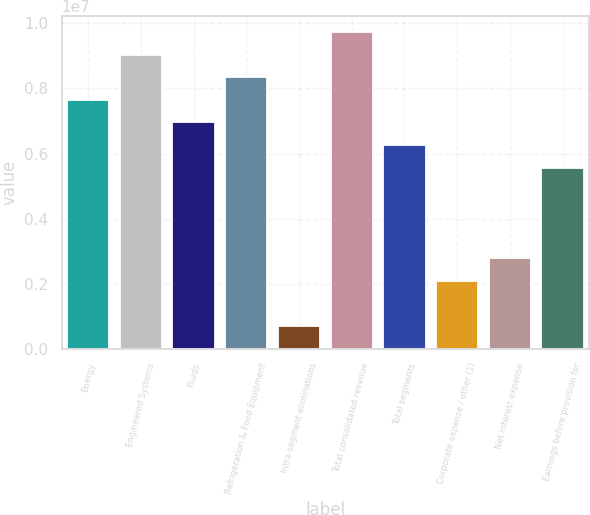Convert chart to OTSL. <chart><loc_0><loc_0><loc_500><loc_500><bar_chart><fcel>Energy<fcel>Engineered Systems<fcel>Fluids<fcel>Refrigeration & Food Equipment<fcel>Intra-segment eliminations<fcel>Total consolidated revenue<fcel>Total segments<fcel>Corporate expense / other (1)<fcel>Net interest expense<fcel>Earnings before provision for<nl><fcel>7.65194e+06<fcel>9.0432e+06<fcel>6.95631e+06<fcel>8.34757e+06<fcel>695645<fcel>9.73883e+06<fcel>6.26068e+06<fcel>2.0869e+06<fcel>2.78253e+06<fcel>5.56505e+06<nl></chart> 